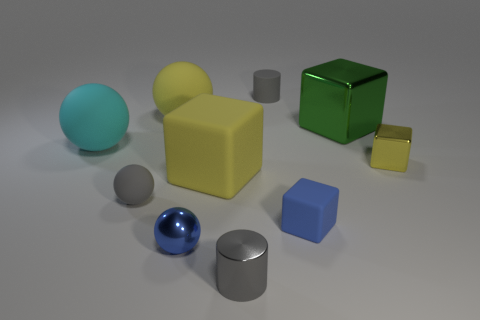Imagine these objects are part of a game, what could be their possible functions? In a game setting, these objects could serve various purposes. The spheres might be tokens or orbs that players collect for points or power-ups. The cubes could be building blocks to create structures or barriers within the game environment, while the smaller objects, like the tiny gold cube, could be keys to unlock new levels or bonus items. 